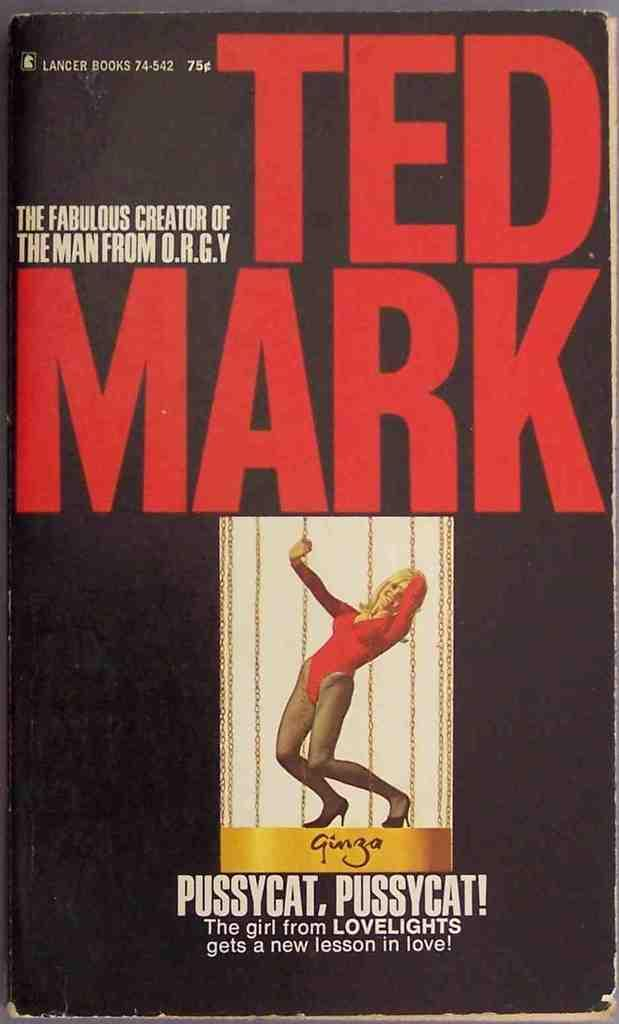What is present in the image that contains information or a message? There is a poster in the image that contains information or a message. How are the texts on the poster differentiated? The texts on the poster are in different colors. What type of image is on the poster? There is a woman's image on the poster. What is a subtle feature on the poster? There is a watermark on the poster. What is the color of the background on the poster? The background of the poster is dark in color. What type of seed is being planted in the image? There is no seed or planting activity present in the image; it features a poster with a woman's image and texts in different colors. What musical instrument is being played in the image? There is no musical instrument or playing activity present in the image; it features a poster with a woman's image and texts in different colors. 